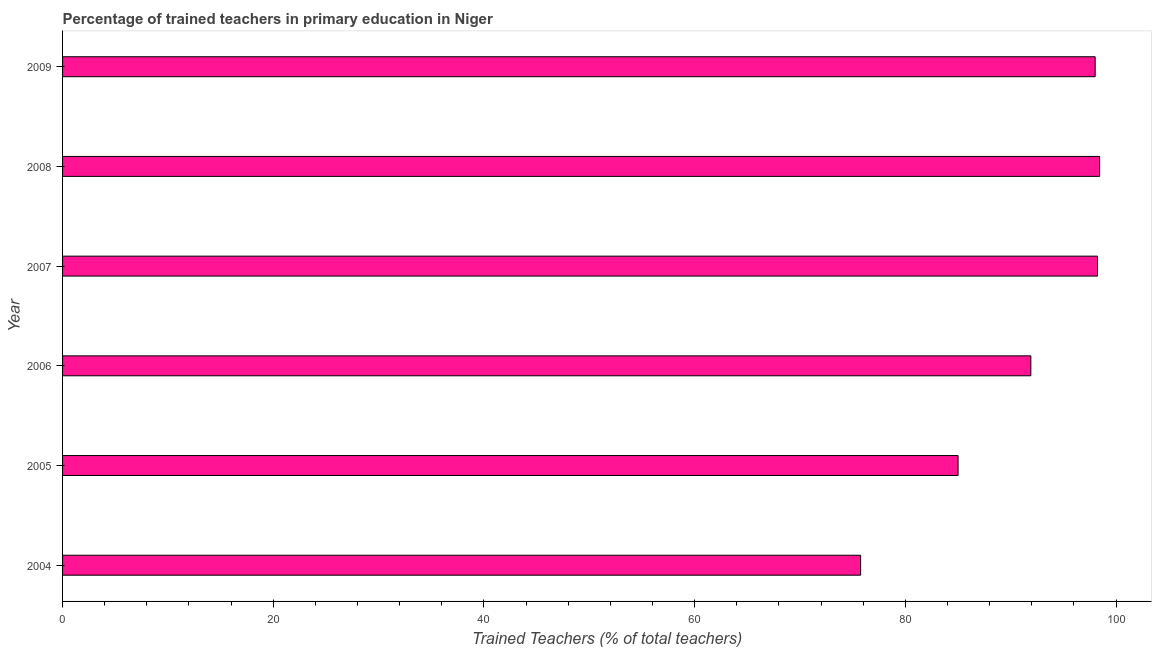What is the title of the graph?
Provide a succinct answer. Percentage of trained teachers in primary education in Niger. What is the label or title of the X-axis?
Offer a very short reply. Trained Teachers (% of total teachers). What is the label or title of the Y-axis?
Ensure brevity in your answer.  Year. What is the percentage of trained teachers in 2006?
Make the answer very short. 91.91. Across all years, what is the maximum percentage of trained teachers?
Your answer should be very brief. 98.44. Across all years, what is the minimum percentage of trained teachers?
Your answer should be very brief. 75.75. In which year was the percentage of trained teachers maximum?
Offer a very short reply. 2008. In which year was the percentage of trained teachers minimum?
Provide a short and direct response. 2004. What is the sum of the percentage of trained teachers?
Your answer should be very brief. 547.35. What is the difference between the percentage of trained teachers in 2006 and 2007?
Your answer should be very brief. -6.33. What is the average percentage of trained teachers per year?
Ensure brevity in your answer.  91.22. What is the median percentage of trained teachers?
Give a very brief answer. 94.96. What is the ratio of the percentage of trained teachers in 2004 to that in 2007?
Your answer should be very brief. 0.77. Is the difference between the percentage of trained teachers in 2004 and 2007 greater than the difference between any two years?
Provide a succinct answer. No. What is the difference between the highest and the second highest percentage of trained teachers?
Your answer should be compact. 0.2. What is the difference between the highest and the lowest percentage of trained teachers?
Make the answer very short. 22.69. Are all the bars in the graph horizontal?
Provide a succinct answer. Yes. How many years are there in the graph?
Your response must be concise. 6. What is the difference between two consecutive major ticks on the X-axis?
Provide a short and direct response. 20. Are the values on the major ticks of X-axis written in scientific E-notation?
Make the answer very short. No. What is the Trained Teachers (% of total teachers) in 2004?
Offer a terse response. 75.75. What is the Trained Teachers (% of total teachers) of 2005?
Offer a terse response. 85. What is the Trained Teachers (% of total teachers) of 2006?
Offer a terse response. 91.91. What is the Trained Teachers (% of total teachers) of 2007?
Your answer should be compact. 98.24. What is the Trained Teachers (% of total teachers) of 2008?
Give a very brief answer. 98.44. What is the Trained Teachers (% of total teachers) of 2009?
Provide a short and direct response. 98.01. What is the difference between the Trained Teachers (% of total teachers) in 2004 and 2005?
Your answer should be compact. -9.25. What is the difference between the Trained Teachers (% of total teachers) in 2004 and 2006?
Keep it short and to the point. -16.16. What is the difference between the Trained Teachers (% of total teachers) in 2004 and 2007?
Your answer should be compact. -22.49. What is the difference between the Trained Teachers (% of total teachers) in 2004 and 2008?
Your response must be concise. -22.69. What is the difference between the Trained Teachers (% of total teachers) in 2004 and 2009?
Keep it short and to the point. -22.26. What is the difference between the Trained Teachers (% of total teachers) in 2005 and 2006?
Provide a short and direct response. -6.91. What is the difference between the Trained Teachers (% of total teachers) in 2005 and 2007?
Offer a terse response. -13.24. What is the difference between the Trained Teachers (% of total teachers) in 2005 and 2008?
Make the answer very short. -13.44. What is the difference between the Trained Teachers (% of total teachers) in 2005 and 2009?
Your response must be concise. -13.01. What is the difference between the Trained Teachers (% of total teachers) in 2006 and 2007?
Your answer should be very brief. -6.33. What is the difference between the Trained Teachers (% of total teachers) in 2006 and 2008?
Give a very brief answer. -6.53. What is the difference between the Trained Teachers (% of total teachers) in 2006 and 2009?
Your answer should be compact. -6.11. What is the difference between the Trained Teachers (% of total teachers) in 2007 and 2008?
Your answer should be very brief. -0.2. What is the difference between the Trained Teachers (% of total teachers) in 2007 and 2009?
Offer a very short reply. 0.22. What is the difference between the Trained Teachers (% of total teachers) in 2008 and 2009?
Offer a very short reply. 0.42. What is the ratio of the Trained Teachers (% of total teachers) in 2004 to that in 2005?
Your answer should be very brief. 0.89. What is the ratio of the Trained Teachers (% of total teachers) in 2004 to that in 2006?
Offer a very short reply. 0.82. What is the ratio of the Trained Teachers (% of total teachers) in 2004 to that in 2007?
Your answer should be very brief. 0.77. What is the ratio of the Trained Teachers (% of total teachers) in 2004 to that in 2008?
Make the answer very short. 0.77. What is the ratio of the Trained Teachers (% of total teachers) in 2004 to that in 2009?
Give a very brief answer. 0.77. What is the ratio of the Trained Teachers (% of total teachers) in 2005 to that in 2006?
Offer a very short reply. 0.93. What is the ratio of the Trained Teachers (% of total teachers) in 2005 to that in 2007?
Offer a very short reply. 0.86. What is the ratio of the Trained Teachers (% of total teachers) in 2005 to that in 2008?
Your answer should be very brief. 0.86. What is the ratio of the Trained Teachers (% of total teachers) in 2005 to that in 2009?
Ensure brevity in your answer.  0.87. What is the ratio of the Trained Teachers (% of total teachers) in 2006 to that in 2007?
Make the answer very short. 0.94. What is the ratio of the Trained Teachers (% of total teachers) in 2006 to that in 2008?
Your answer should be compact. 0.93. What is the ratio of the Trained Teachers (% of total teachers) in 2006 to that in 2009?
Provide a succinct answer. 0.94. What is the ratio of the Trained Teachers (% of total teachers) in 2007 to that in 2008?
Ensure brevity in your answer.  1. What is the ratio of the Trained Teachers (% of total teachers) in 2007 to that in 2009?
Provide a succinct answer. 1. 